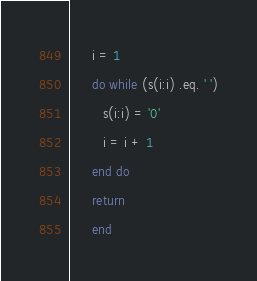<code> <loc_0><loc_0><loc_500><loc_500><_FORTRAN_>      i = 1
      do while (s(i:i) .eq. ' ')
         s(i:i) = '0'
         i = i + 1
      end do
      return
      end
</code> 